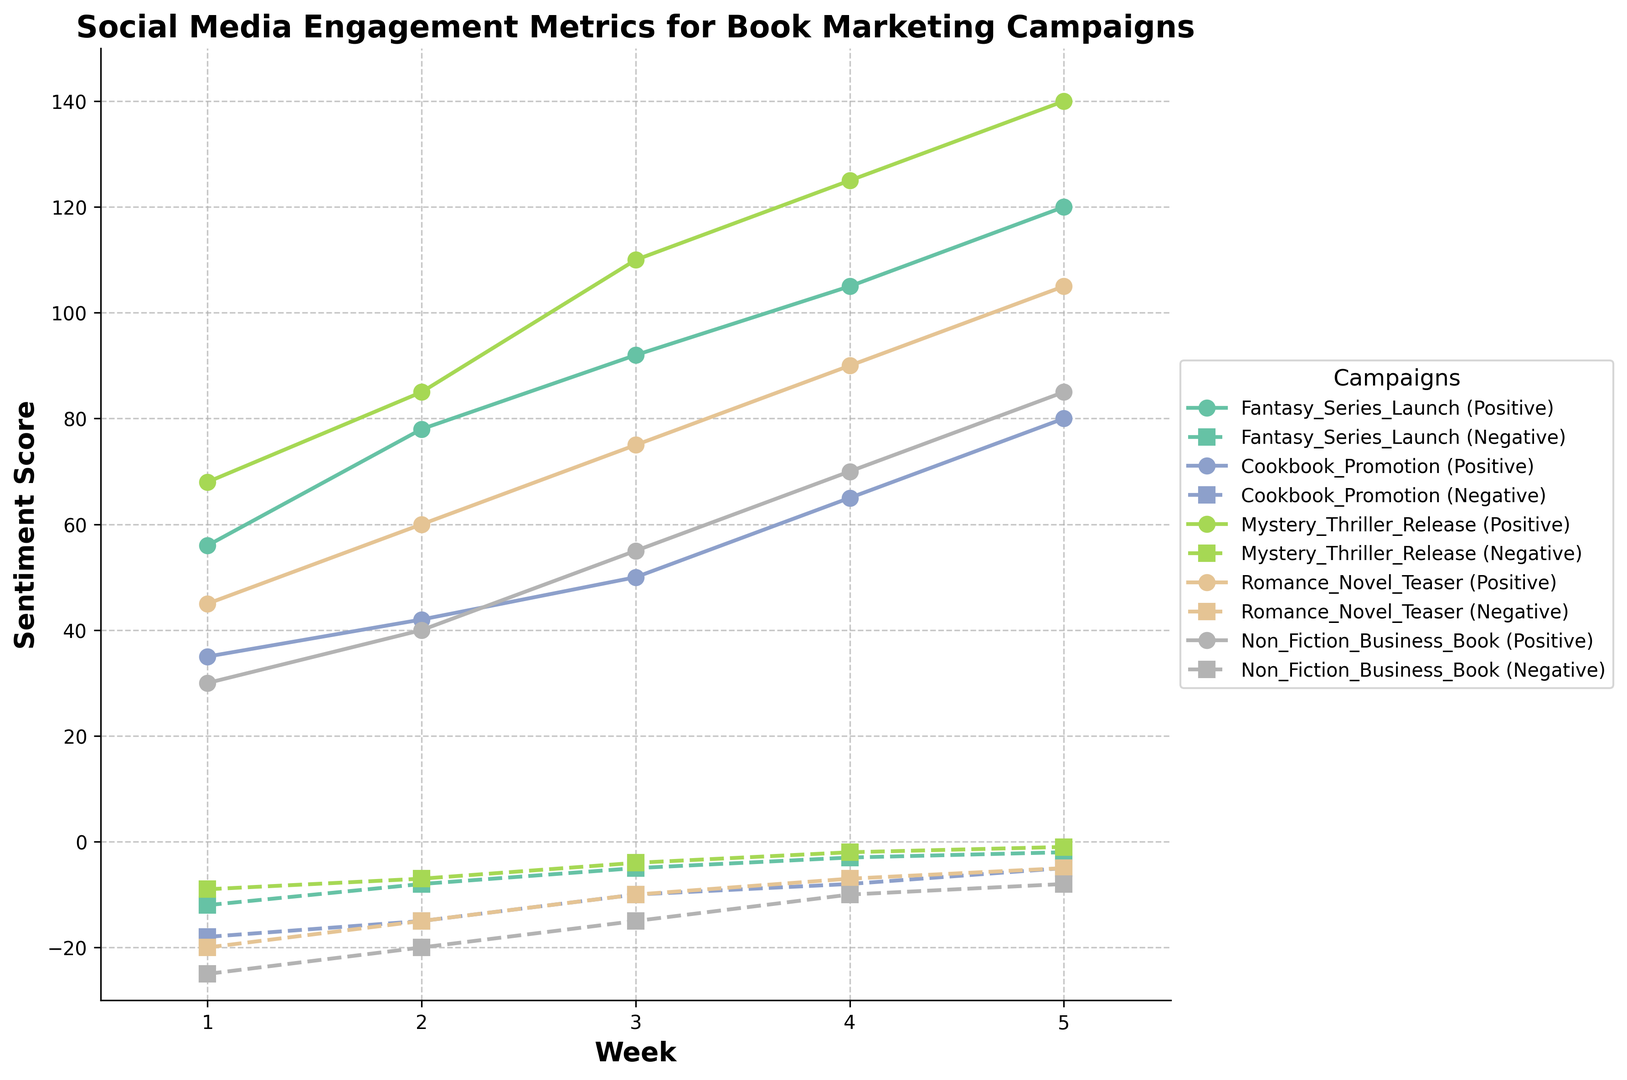Which campaign has the highest positive sentiment in Week 5? The Fantasy_Series_Launch campaign has a positive sentiment score of 120 in Week 5. However, the Mystery_Thriller_Release campaign surpasses this with a score of 140.
Answer: Mystery_Thriller_Release Which campaign shows the most improvement in positive sentiment from Week 1 to Week 5? Subtracting Week 1 positive sentiment from Week 5 positive sentiment for each campaign: Fantasy_Series_Launch (120-56=64), Cookbook_Promotion (80-35=45), Mystery_Thriller_Release (140-68=72), Romance_Novel_Teaser (105-45=60), Non_Fiction_Business_Book (85-30=55). The campaign with the most improvement is Mystery_Thriller_Release (72).
Answer: Mystery_Thriller_Release Which campaign consistently has the lowest negative sentiment across all weeks? Looking at the negative sentiment scores: Fantasy_Series_Launch (-12, -8, -5, -3, -2), Cookbook_Promotion (-18, -15, -10, -8, -5), Mystery_Thriller_Release (-9, -7, -4, -2, -1), Romance_Novel_Teaser (-20, -15, -10, -7, -5), Non_Fiction_Business_Book (-25, -20, -15, -10, -8). Mystery_Thriller_Release consistently has the lowest negative sentiment.
Answer: Mystery_Thriller_Release Which campaign showed the steepest decline in negative sentiment from Week 1 to Week 5? Calculate the decline in negative sentiment for each campaign: Fantasy_Series_Launch (-12 - (-2) = -10), Cookbook_Promotion (-18 - (-5) = -13), Mystery_Thriller_Release (-9 - (-1) = -8), Romance_Novel_Teaser (-20 - (-5) = -15), Non_Fiction_Business_Book (-25 - (-8) = -17). The steepest decline is seen in Non_Fiction_Business_Book (-17).
Answer: Non_Fiction_Business_Book By how many points did the positive sentiment for the Romance_Novel_Teaser exceed the negative sentiment in Week 3? Positive sentiment for Romance_Novel_Teaser in Week 3 is 75, and the negative sentiment is -10. The difference is 75 - (-10) = 75 + 10 = 85 points.
Answer: 85 points Which two campaigns have the largest difference in positive sentiment in Week 2? Positive sentiment scores in Week 2 for all campaigns: Fantasy_Series_Launch (78), Cookbook_Promotion (42), Mystery_Thriller_Release (85), Romance_Novel_Teaser (60), Non_Fiction_Business_Book (40). The largest difference is between Non_Fiction_Business_Book (40) and Fantasy_Series_Launch (78), which is 78 - 40 = 38.
Answer: Fantasy_Series_Launch and Non_Fiction_Business_Book What's the average positive sentiment score for the Cookbook_Promotion from Week 1 to Week 5? Sum the positive sentiment scores for Cookbook_Promotion (35 + 42 + 50 + 65 + 80) = 272. The average is 272 / 5 = 54.4.
Answer: 54.4 What is the trend of positive sentiment for the Non_Fiction_Business_Book campaign over the weeks? Positive sentiment for Non_Fiction_Business_Book from Week 1 to Week 5 is 30, 40, 55, 70, and 85. The trend shows a steady increase each week.
Answer: Increasing Which campaign had the lowest positive sentiment in Week 1? The Week 1 positive sentiments are: Fantasy_Series_Launch (56), Cookbook_Promotion (35), Mystery_Thriller_Release (68), Romance_Novel_Teaser (45), Non_Fiction_Business_Book (30). The lowest positive sentiment is for Non_Fiction_Business_Book at 30.
Answer: Non_Fiction_Business_Book 